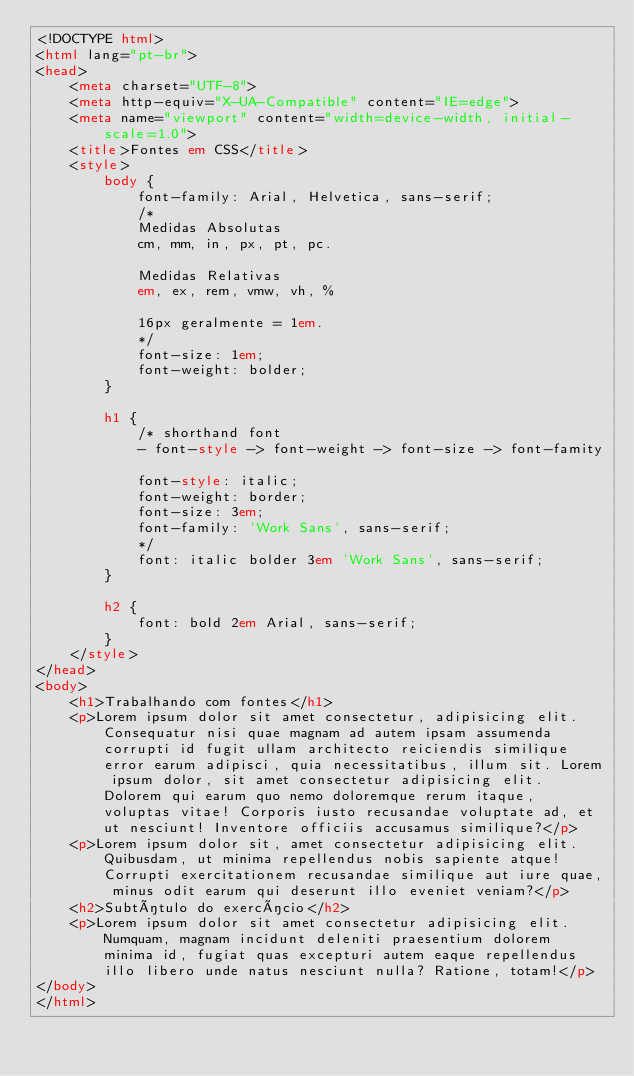<code> <loc_0><loc_0><loc_500><loc_500><_HTML_><!DOCTYPE html>
<html lang="pt-br">
<head>
    <meta charset="UTF-8">
    <meta http-equiv="X-UA-Compatible" content="IE=edge">
    <meta name="viewport" content="width=device-width, initial-scale=1.0">
    <title>Fontes em CSS</title>
    <style>
        body {
            font-family: Arial, Helvetica, sans-serif;
            /*
            Medidas Absolutas
            cm, mm, in, px, pt, pc.

            Medidas Relativas
            em, ex, rem, vmw, vh, %

            16px geralmente = 1em.
            */
            font-size: 1em;
            font-weight: bolder;
        }

        h1 {
            /* shorthand font
            - font-style -> font-weight -> font-size -> font-famity

            font-style: italic;
            font-weight: border;
            font-size: 3em;
            font-family: 'Work Sans', sans-serif;
            */
            font: italic bolder 3em 'Work Sans', sans-serif;
        }

        h2 {
            font: bold 2em Arial, sans-serif;
        }
    </style>
</head>
<body>
    <h1>Trabalhando com fontes</h1>
    <p>Lorem ipsum dolor sit amet consectetur, adipisicing elit. Consequatur nisi quae magnam ad autem ipsam assumenda corrupti id fugit ullam architecto reiciendis similique error earum adipisci, quia necessitatibus, illum sit. Lorem ipsum dolor, sit amet consectetur adipisicing elit. Dolorem qui earum quo nemo doloremque rerum itaque, voluptas vitae! Corporis iusto recusandae voluptate ad, et ut nesciunt! Inventore officiis accusamus similique?</p>
    <p>Lorem ipsum dolor sit, amet consectetur adipisicing elit. Quibusdam, ut minima repellendus nobis sapiente atque! Corrupti exercitationem recusandae similique aut iure quae, minus odit earum qui deserunt illo eveniet veniam?</p>
    <h2>Subtítulo do exercício</h2>
    <p>Lorem ipsum dolor sit amet consectetur adipisicing elit. Numquam, magnam incidunt deleniti praesentium dolorem minima id, fugiat quas excepturi autem eaque repellendus illo libero unde natus nesciunt nulla? Ratione, totam!</p>
</body>
</html></code> 